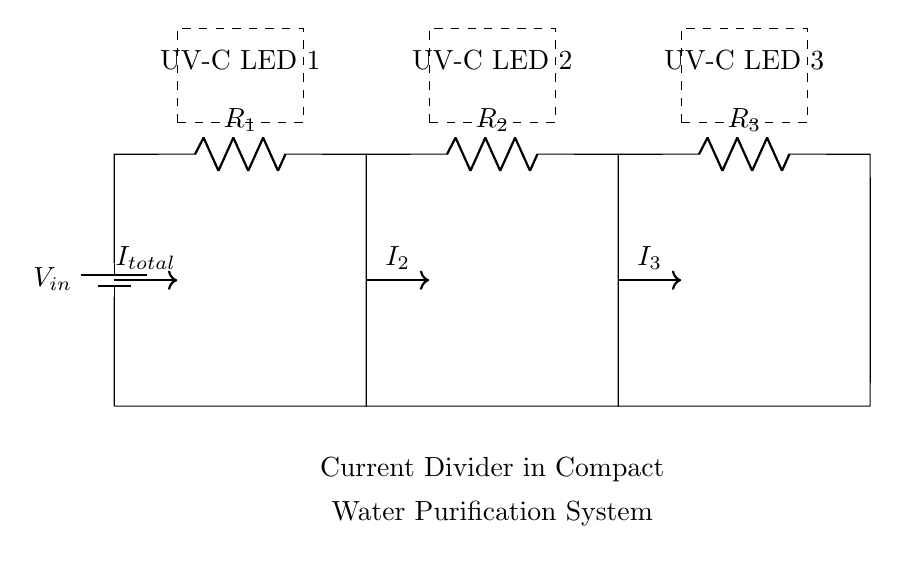What is the total current entering the circuit? The total current is represented as "I_total" in the diagram, indicating the current that flows from the battery before it is divided among the branches.
Answer: I_total How many resistors are in the circuit? The diagram shows three resistors labeled as R_1, R_2, and R_3, which are responsible for dividing the current in the circuit.
Answer: 3 What components are indicated as UV-C LEDs? The circuit diagram labels three LEDs at the top portion, indicating that these components are UV-C LEDs meant for the water purification process.
Answer: UV-C LED 1, UV-C LED 2, UV-C LED 3 What happens to the current in the circuit? The current (I_total) splits into I_2 and I_3 as it passes through the resistors, demonstrating the current dividing behavior of the circuit.
Answer: Splits What is the purpose of the current divider in this circuit? The purpose of the current divider is to ensure that the total current from the battery is distributed among the UV-C LEDs, optimizing their performance and increasing the effectiveness of the purification system.
Answer: To distribute current How does the resistance value affect the current through each LED? The resistance values R_1, R_2, and R_3 affect how much current each LED receives according to Ohm's law, with lower resistance leading to higher current in that branch, thus more light output from the LED.
Answer: Higher resistance = lower current 